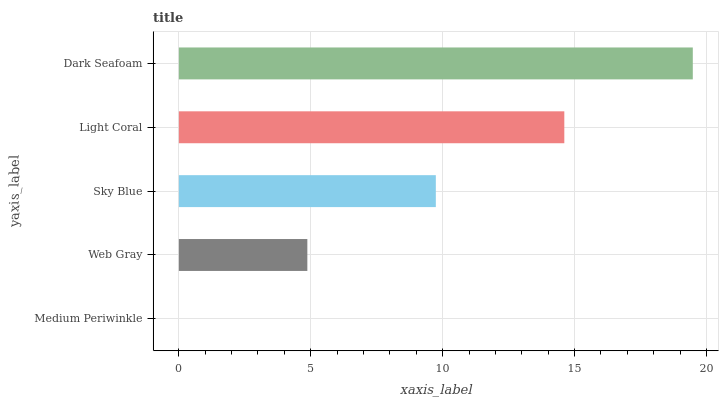Is Medium Periwinkle the minimum?
Answer yes or no. Yes. Is Dark Seafoam the maximum?
Answer yes or no. Yes. Is Web Gray the minimum?
Answer yes or no. No. Is Web Gray the maximum?
Answer yes or no. No. Is Web Gray greater than Medium Periwinkle?
Answer yes or no. Yes. Is Medium Periwinkle less than Web Gray?
Answer yes or no. Yes. Is Medium Periwinkle greater than Web Gray?
Answer yes or no. No. Is Web Gray less than Medium Periwinkle?
Answer yes or no. No. Is Sky Blue the high median?
Answer yes or no. Yes. Is Sky Blue the low median?
Answer yes or no. Yes. Is Web Gray the high median?
Answer yes or no. No. Is Light Coral the low median?
Answer yes or no. No. 